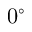Convert formula to latex. <formula><loc_0><loc_0><loc_500><loc_500>0 ^ { \circ }</formula> 